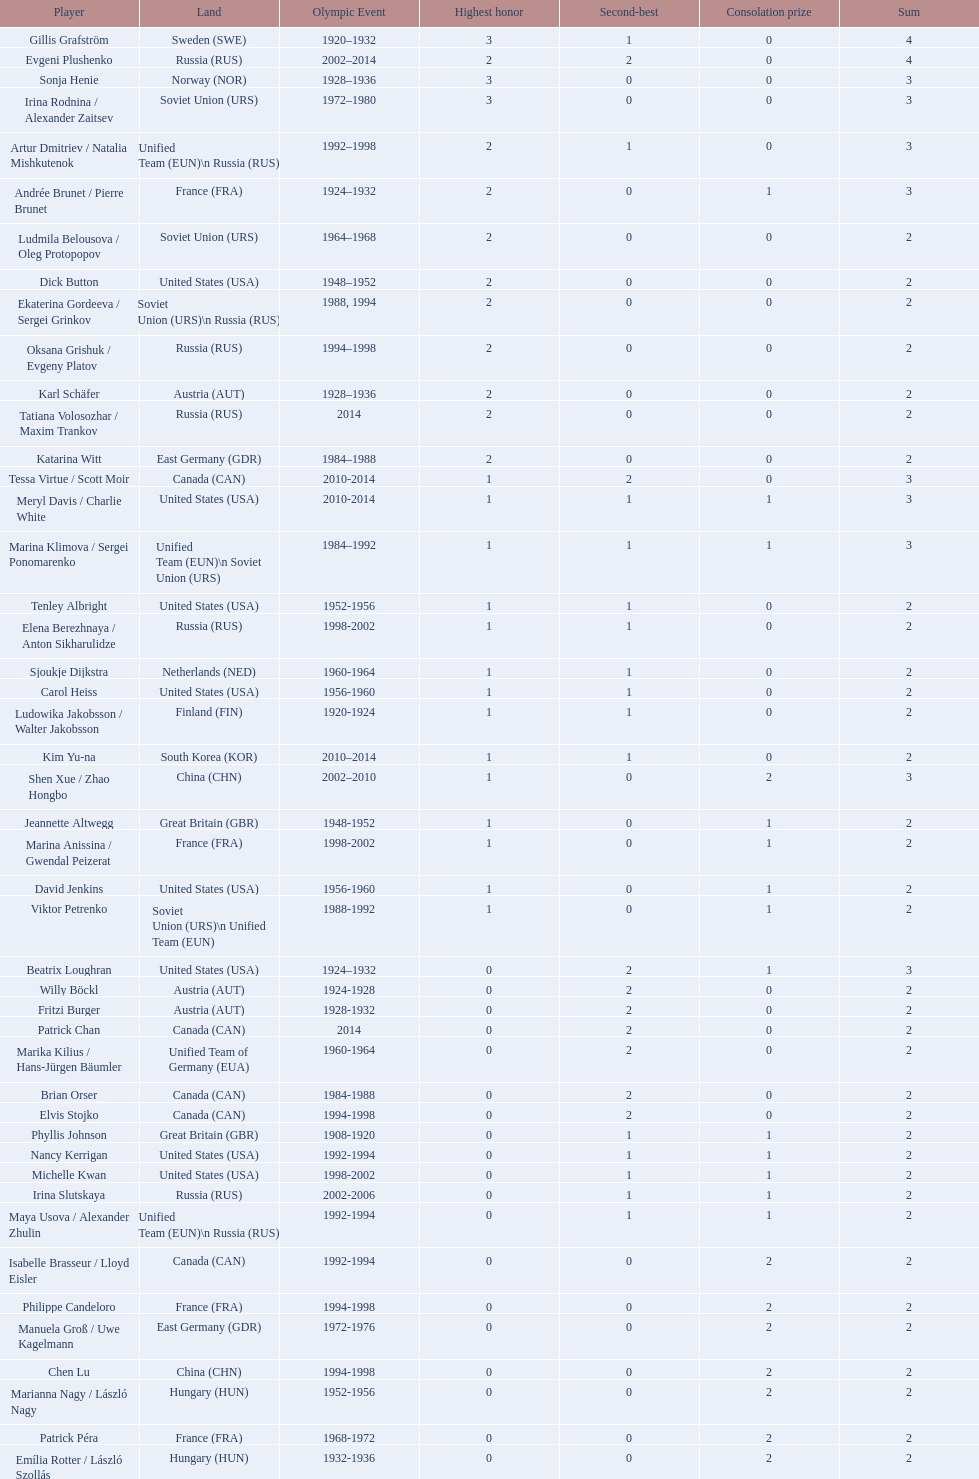Who is the athlete that came from south korea following the year 2010? Kim Yu-na. 